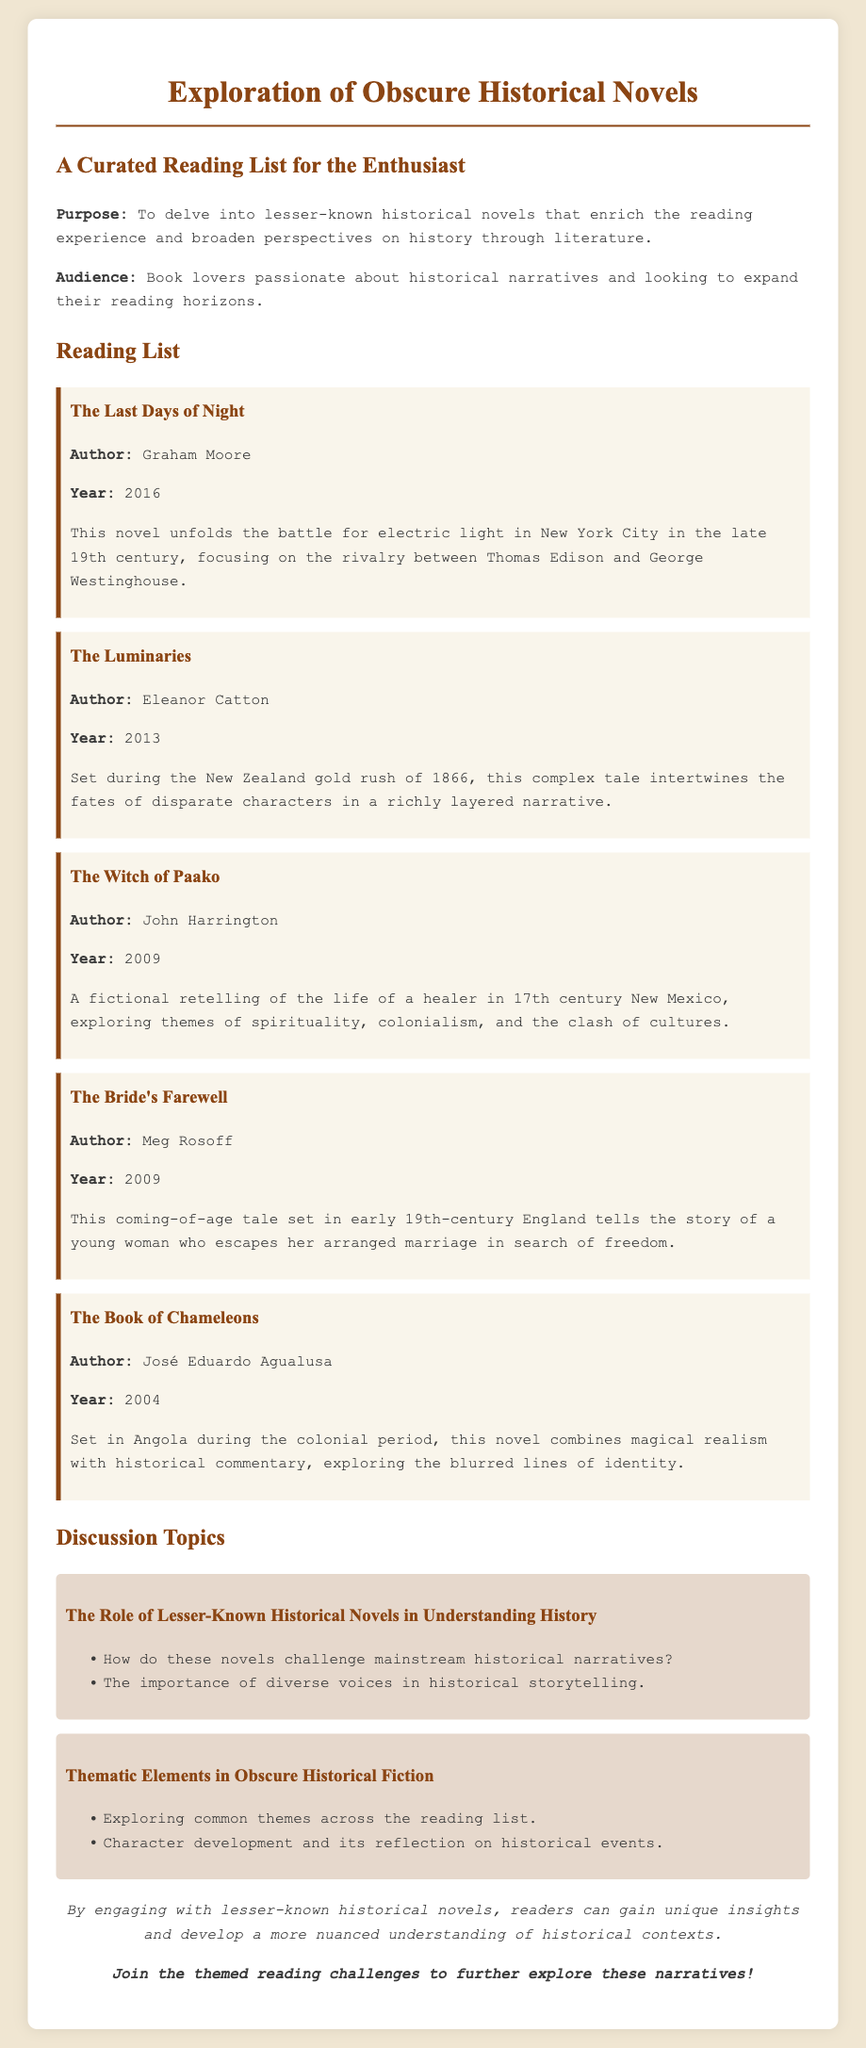What is the title of the first book listed? The title of the first book is presented at the top of the book section in the document.
Answer: The Last Days of Night Who is the author of "The Luminaries"? The author's name is explicitly mentioned in the description of "The Luminaries."
Answer: Eleanor Catton In what year was "The Witch of Paako" published? The publication year for "The Witch of Paako" is stated clearly in the book entry.
Answer: 2009 What thematic element is discussed in the second topic? The second discussion topic is about specific thematic elements related to the reading list, outlined in the document.
Answer: Thematic Elements in Obscure Historical Fiction How many books are included in the reading list? The document lists all the books under the reading list section, which can be counted.
Answer: 5 